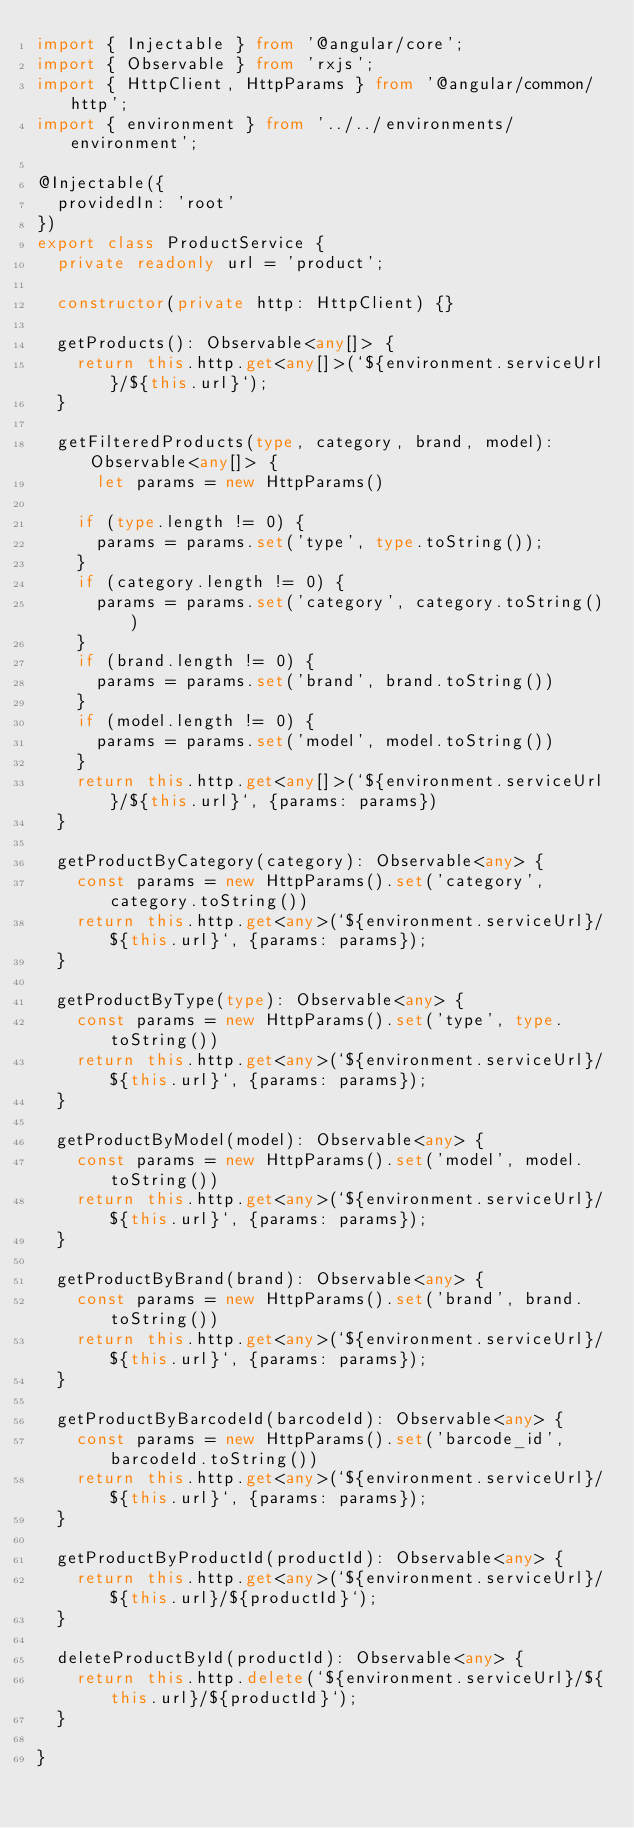Convert code to text. <code><loc_0><loc_0><loc_500><loc_500><_TypeScript_>import { Injectable } from '@angular/core';
import { Observable } from 'rxjs';
import { HttpClient, HttpParams } from '@angular/common/http';
import { environment } from '../../environments/environment';

@Injectable({
  providedIn: 'root'
})
export class ProductService {
  private readonly url = 'product';

  constructor(private http: HttpClient) {}
    
  getProducts(): Observable<any[]> {
    return this.http.get<any[]>(`${environment.serviceUrl}/${this.url}`);
  }

  getFilteredProducts(type, category, brand, model): Observable<any[]> {
      let params = new HttpParams()
      
    if (type.length != 0) {
      params = params.set('type', type.toString());
    }
    if (category.length != 0) {
      params = params.set('category', category.toString())
    }
    if (brand.length != 0) {
      params = params.set('brand', brand.toString())
    }
    if (model.length != 0) {
      params = params.set('model', model.toString())
    }
    return this.http.get<any[]>(`${environment.serviceUrl}/${this.url}`, {params: params})
  }
  
  getProductByCategory(category): Observable<any> {
    const params = new HttpParams().set('category', category.toString())
    return this.http.get<any>(`${environment.serviceUrl}/${this.url}`, {params: params});
  }

  getProductByType(type): Observable<any> {
    const params = new HttpParams().set('type', type.toString())
    return this.http.get<any>(`${environment.serviceUrl}/${this.url}`, {params: params});
  }

  getProductByModel(model): Observable<any> {
    const params = new HttpParams().set('model', model.toString())
    return this.http.get<any>(`${environment.serviceUrl}/${this.url}`, {params: params});
  }

  getProductByBrand(brand): Observable<any> {
    const params = new HttpParams().set('brand', brand.toString())
    return this.http.get<any>(`${environment.serviceUrl}/${this.url}`, {params: params});
  }

  getProductByBarcodeId(barcodeId): Observable<any> {
    const params = new HttpParams().set('barcode_id', barcodeId.toString())
    return this.http.get<any>(`${environment.serviceUrl}/${this.url}`, {params: params});
  }

  getProductByProductId(productId): Observable<any> {
    return this.http.get<any>(`${environment.serviceUrl}/${this.url}/${productId}`);
  }

  deleteProductById(productId): Observable<any> {
    return this.http.delete(`${environment.serviceUrl}/${this.url}/${productId}`);
  }

}
</code> 